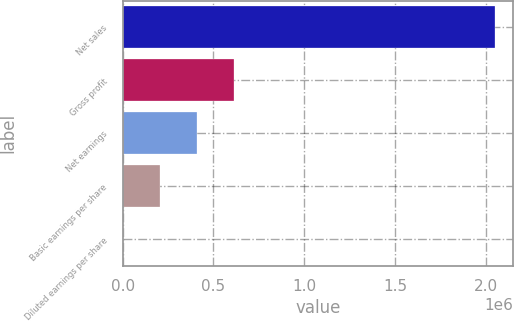<chart> <loc_0><loc_0><loc_500><loc_500><bar_chart><fcel>Net sales<fcel>Gross profit<fcel>Net earnings<fcel>Basic earnings per share<fcel>Diluted earnings per share<nl><fcel>2.04825e+06<fcel>614476<fcel>409651<fcel>204827<fcel>2.08<nl></chart> 